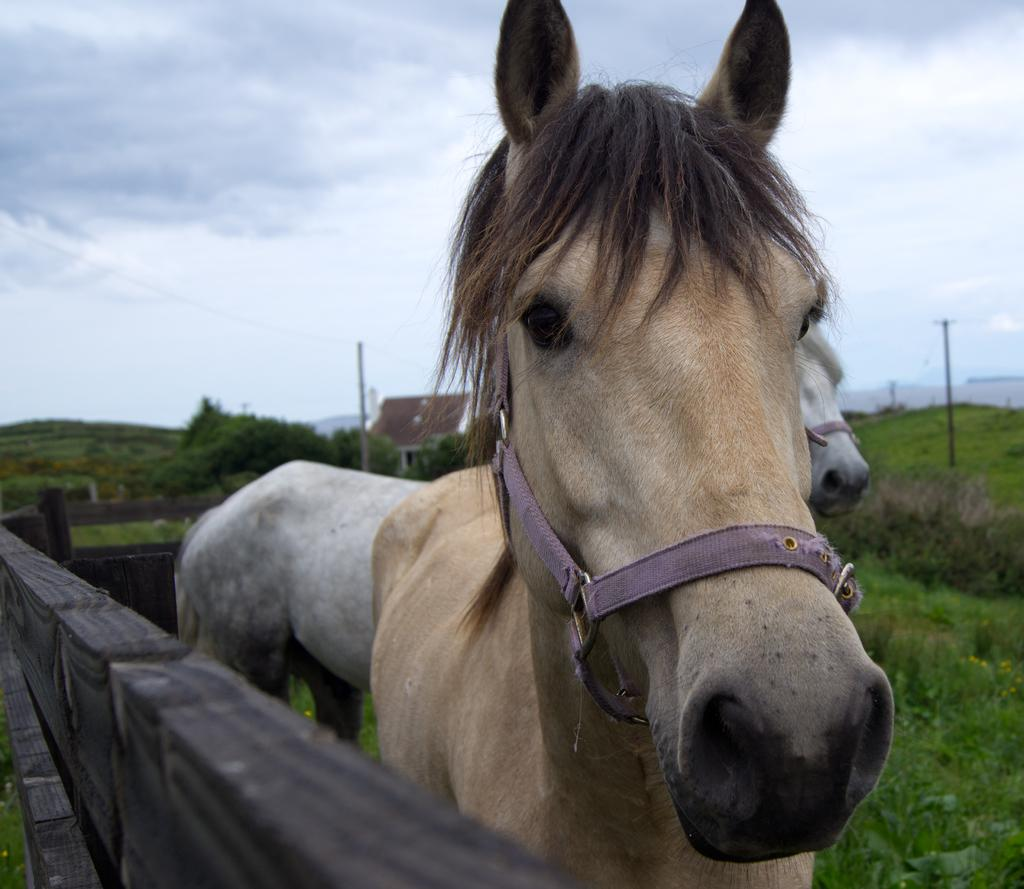What animals can be seen in the image? There are horses in the image. Where are the horses located? The horses are standing on grassland. What type of enclosure surrounds the grassland? The grassland is enclosed by a wooden fence. What can be seen in the background of the image? There is a home and trees in the background of the image. What is visible in the sky in the image? The sky is visible in the background of the image, and clouds are present. What type of trousers are the horses wearing in the image? Horses do not wear trousers, so this detail cannot be found in the image. 